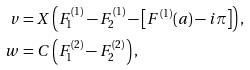<formula> <loc_0><loc_0><loc_500><loc_500>v & = X \left ( F _ { 1 } ^ { ( 1 ) } - F _ { 2 } ^ { ( 1 ) } - \left [ F ^ { ( 1 ) } ( a ) - i \pi \right ] \right ) , \\ w & = C \left ( F _ { 1 } ^ { ( 2 ) } - F _ { 2 } ^ { ( 2 ) } \right ) ,</formula> 